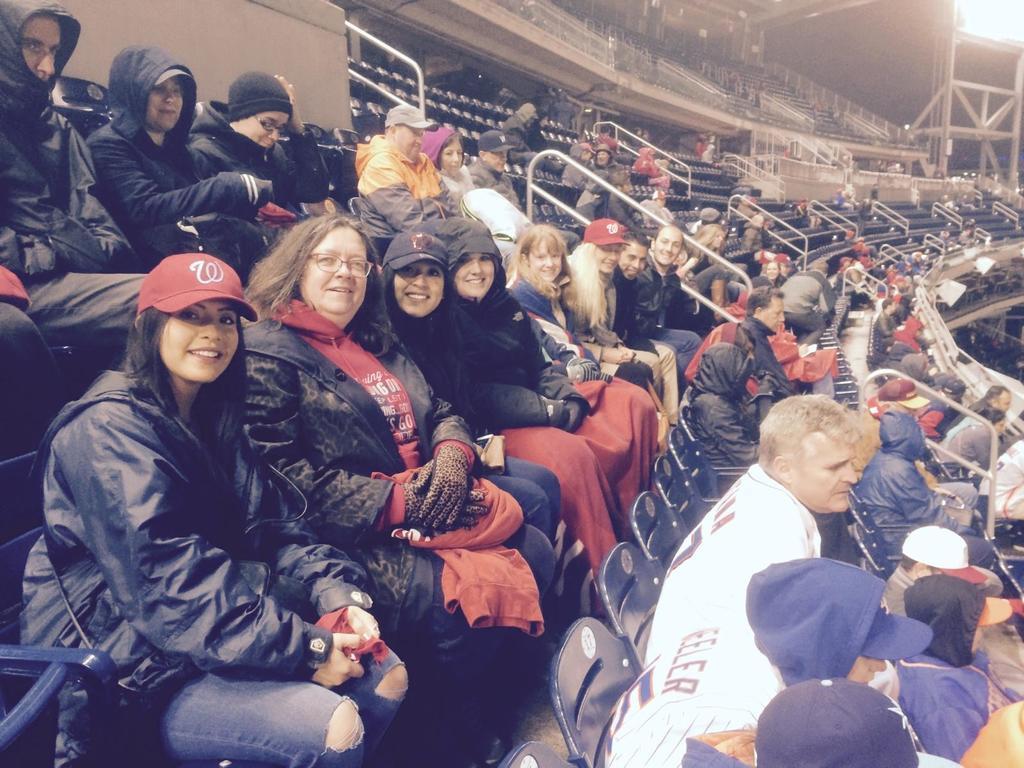Describe this image in one or two sentences. In this image we can see men and women are sitting on the sitting area of the stadium. 